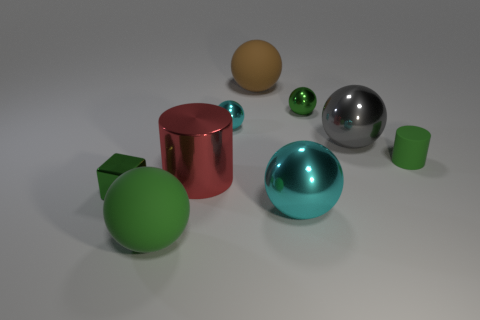Is there any other thing that is the same size as the red cylinder?
Your response must be concise. Yes. There is a metal block; is its color the same as the big matte thing that is in front of the tiny green matte thing?
Keep it short and to the point. Yes. There is a big shiny cylinder; what number of red objects are in front of it?
Your answer should be compact. 0. Is the number of green spheres less than the number of small blue objects?
Offer a terse response. No. There is a green object that is both to the left of the rubber cylinder and on the right side of the large cylinder; what is its size?
Provide a short and direct response. Small. There is a big shiny ball in front of the big metal cylinder; is it the same color as the shiny cube?
Make the answer very short. No. Are there fewer gray shiny objects that are to the left of the metallic cube than matte balls?
Your answer should be compact. Yes. The large cyan thing that is made of the same material as the green block is what shape?
Provide a short and direct response. Sphere. Do the large red cylinder and the large gray ball have the same material?
Provide a short and direct response. Yes. Is the number of cylinders behind the tiny green cylinder less than the number of tiny cyan metallic spheres that are right of the large red object?
Provide a succinct answer. Yes. 